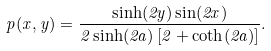<formula> <loc_0><loc_0><loc_500><loc_500>p ( x , y ) = \frac { \sinh ( 2 y ) \sin ( 2 x ) } { 2 \sinh ( 2 a ) \left [ 2 + \coth ( 2 a ) \right ] } .</formula> 